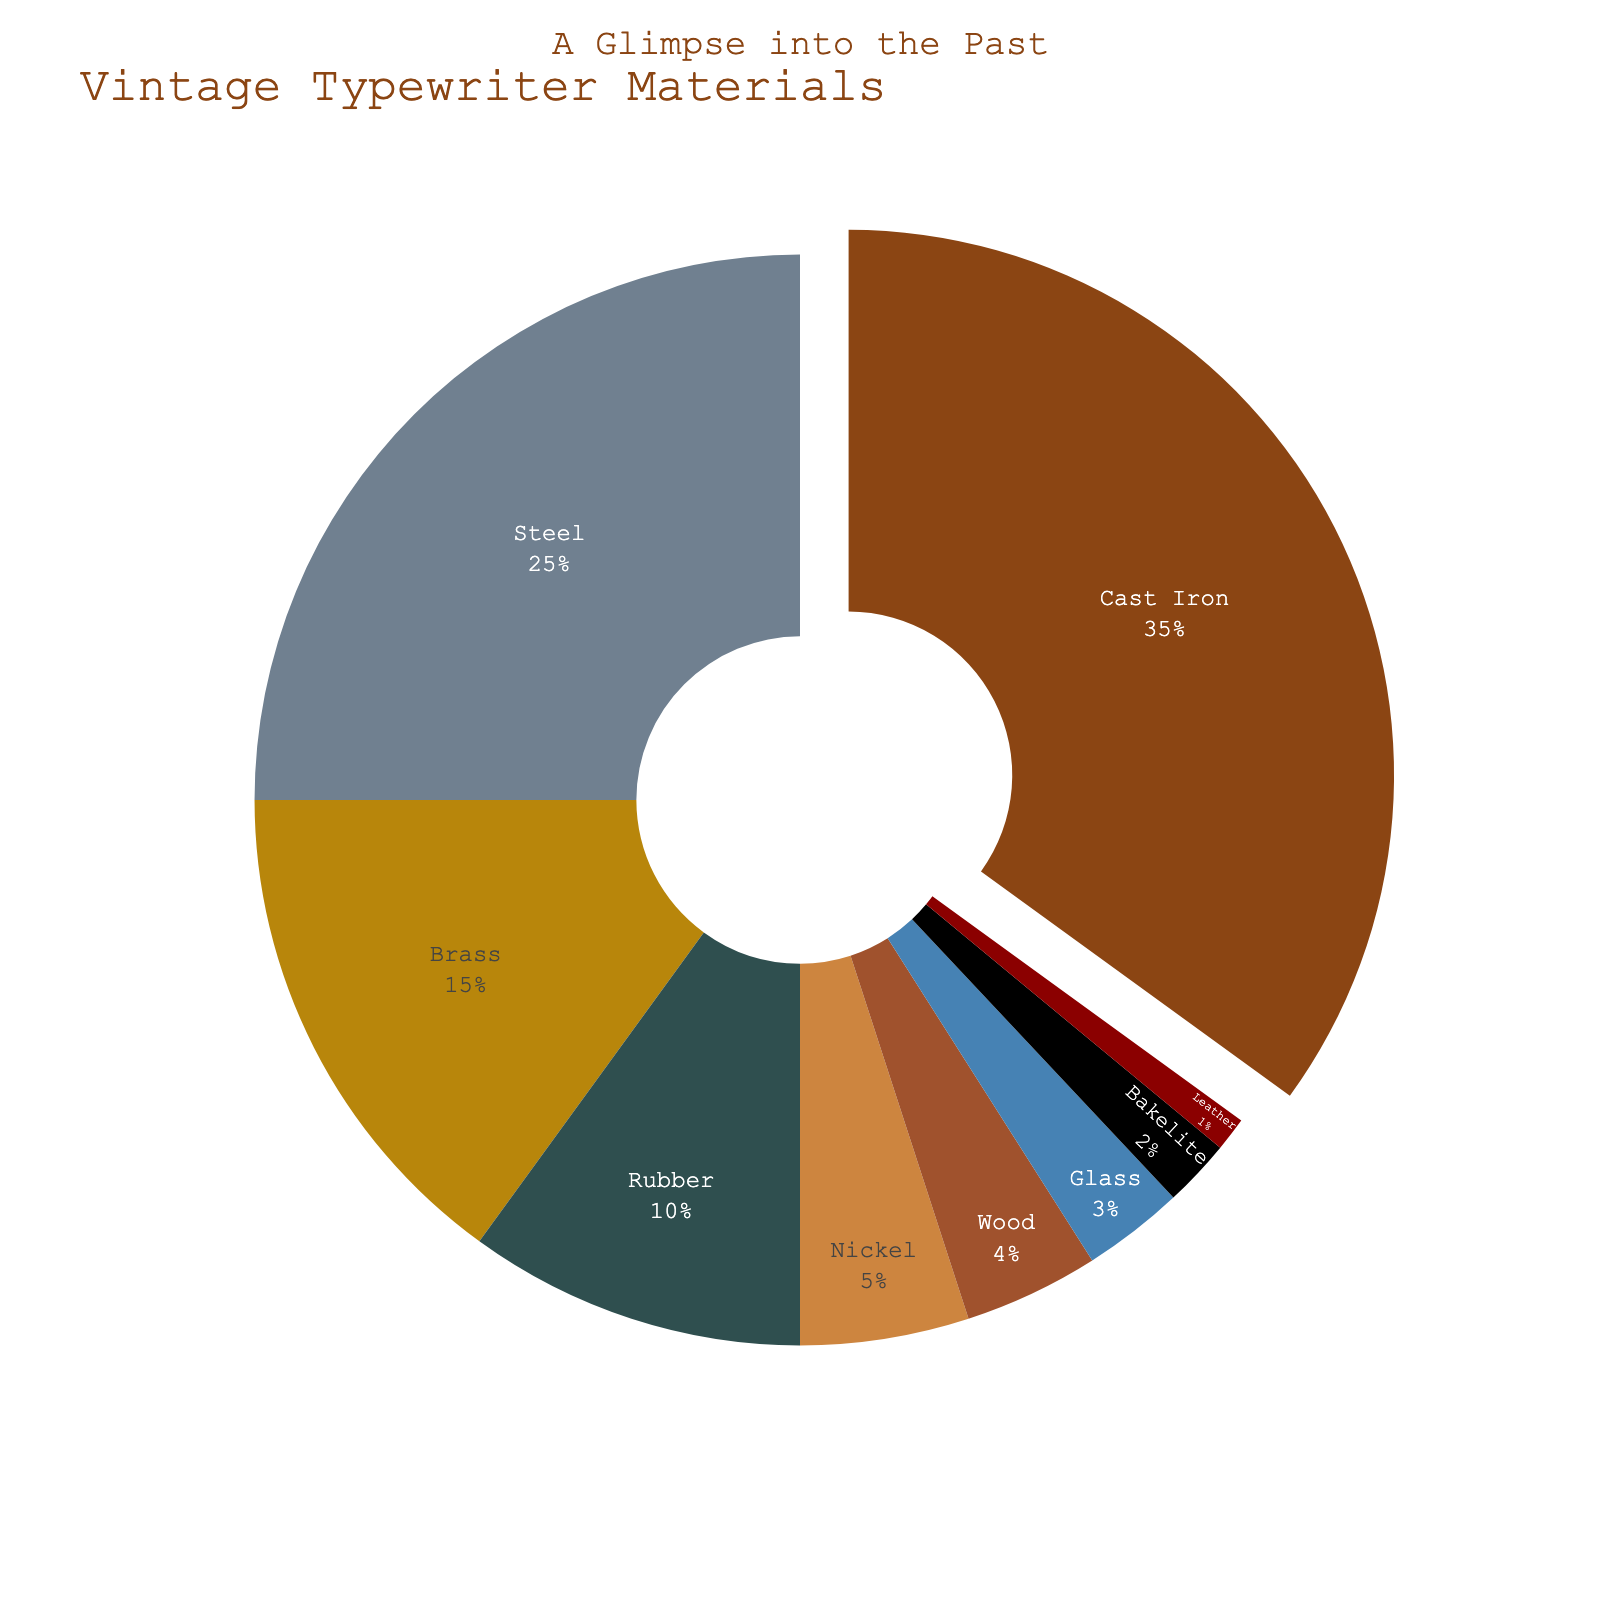What's the most abundant material used in vintage typewriters? The pie chart shows that Cast Iron is represented by the largest segment.
Answer: Cast Iron Which two materials have the smallest percentages? By examining the smallest segments of the pie chart, Bakelite and Leather have the lowest values.
Answer: Bakelite and Leather What's the combined percentage of Nickel, Wood, and Glass? Sum the percentages of Nickel (5%), Wood (4%), and Glass (3%): 5 + 4 + 3.
Answer: 12% Is Steel used more or less than Brass in vintage typewriters? Compare the segments for Steel (25%) and Brass (15%). Steel is greater than Brass.
Answer: More How does the percentage of Rubber compare to the sum of Glass and Bakelite? Rubber is 10%, while the sum of Glass (3%) and Bakelite (2%) is 5%. Rubber is greater.
Answer: Greater What's the difference in percentage between the most and least used materials? Subtract the percentage of Leather (1%) from the percentage of Cast Iron (35%): 35 - 1.
Answer: 34% If the 'pull' effect was applied to emphasize the largest segment, which material would that be? The 'pull' effect is applied to the largest segment, which is Cast Iron.
Answer: Cast Iron Which material has the second smallest percentage, and what is it? The second smallest segment is Bakelite, which has a percentage of 2%.
Answer: Bakelite, 2% What's the percentage difference between the most used metal (Cast Iron) and the least used non-metal (Leather)? Subtract Leather's percentage (1%) from Cast Iron's percentage (35%): 35 - 1.
Answer: 34% 